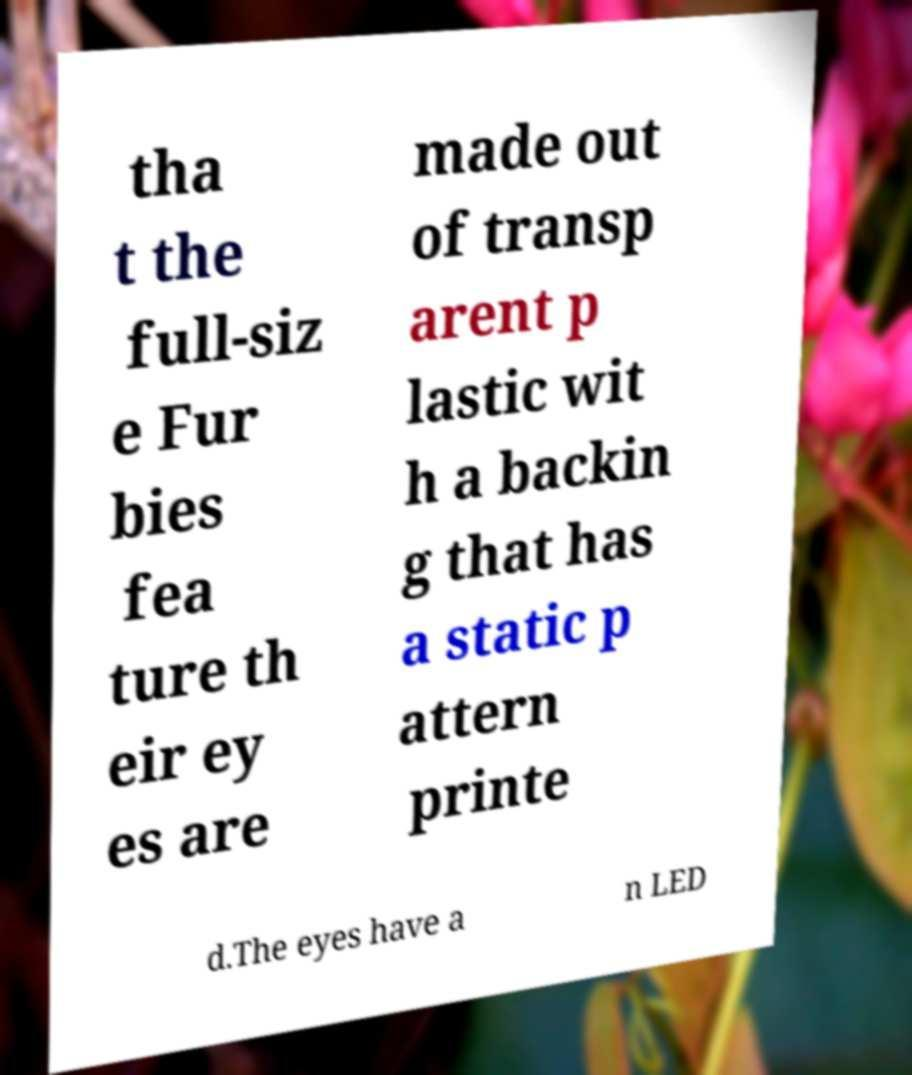Please identify and transcribe the text found in this image. tha t the full-siz e Fur bies fea ture th eir ey es are made out of transp arent p lastic wit h a backin g that has a static p attern printe d.The eyes have a n LED 